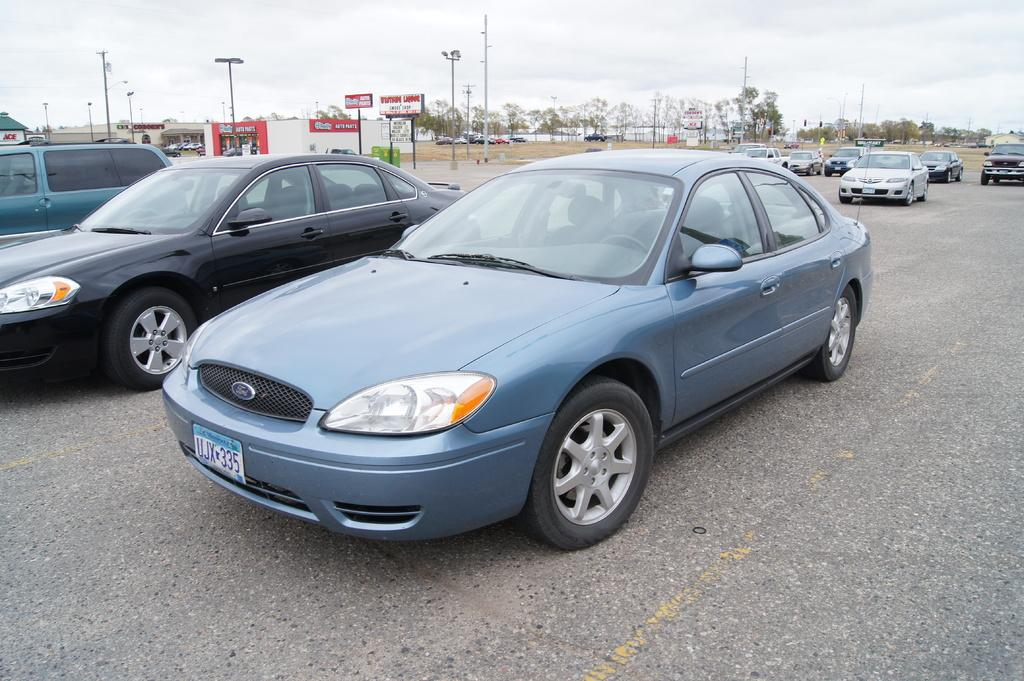What can be seen on the road in the image? There are vehicles on the road in the image. What is visible in the background behind the vehicles? There are hoardings and a building in the background. Where are additional vehicles located in the image? There are vehicles parked on the ground near the building. What structures are present in the image? There are poles in the image. What type of natural elements can be seen in the image? There are trees in the image. What is visible in the sky in the image? There are clouds in the sky. What letter is being used to communicate with the earth in the image? There is no letter or communication with the earth present in the image. How many bits of information can be seen being transmitted between the vehicles in the image? There is no transmission of bits of information between the vehicles in the image. 